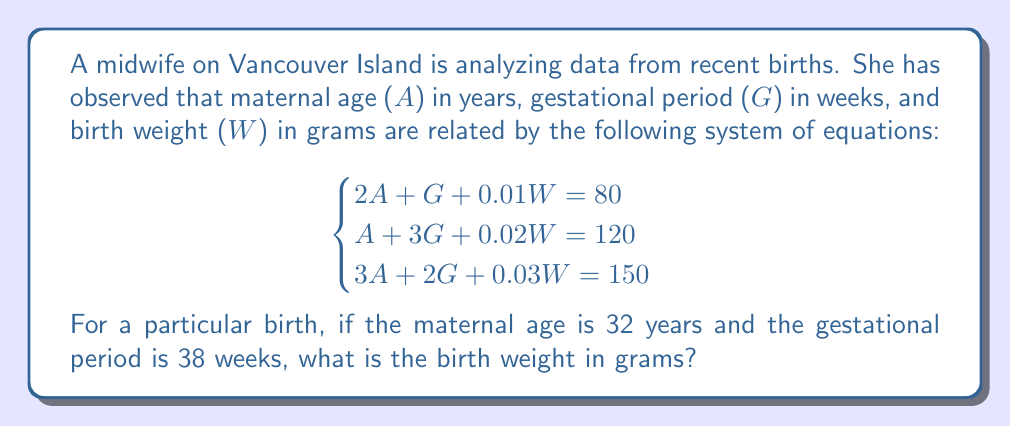Give your solution to this math problem. Let's solve this system of equations step by step:

1) We're given that A = 32 and G = 38. We need to find W.

2) Substitute these values into each equation:

   Equation 1: $2(32) + 38 + 0.01W = 80$
   Equation 2: $32 + 3(38) + 0.02W = 120$
   Equation 3: $3(32) + 2(38) + 0.03W = 150$

3) Simplify:

   Equation 1: $64 + 38 + 0.01W = 80$
   Equation 2: $32 + 114 + 0.02W = 120$
   Equation 3: $96 + 76 + 0.03W = 150$

4) Subtract the known values from both sides:

   Equation 1: $0.01W = -22$
   Equation 2: $0.02W = -26$
   Equation 3: $0.03W = -22$

5) Solve each equation for W:

   Equation 1: $W = -22 / 0.01 = -2200$
   Equation 2: $W = -26 / 0.02 = -1300$
   Equation 3: $W = -22 / 0.03 = -733.33$

6) The only positive and realistic solution is from Equation 2:

   $W = 3300$ grams

This makes sense as it's a typical birth weight (about 7.3 pounds).
Answer: The birth weight is 3300 grams. 